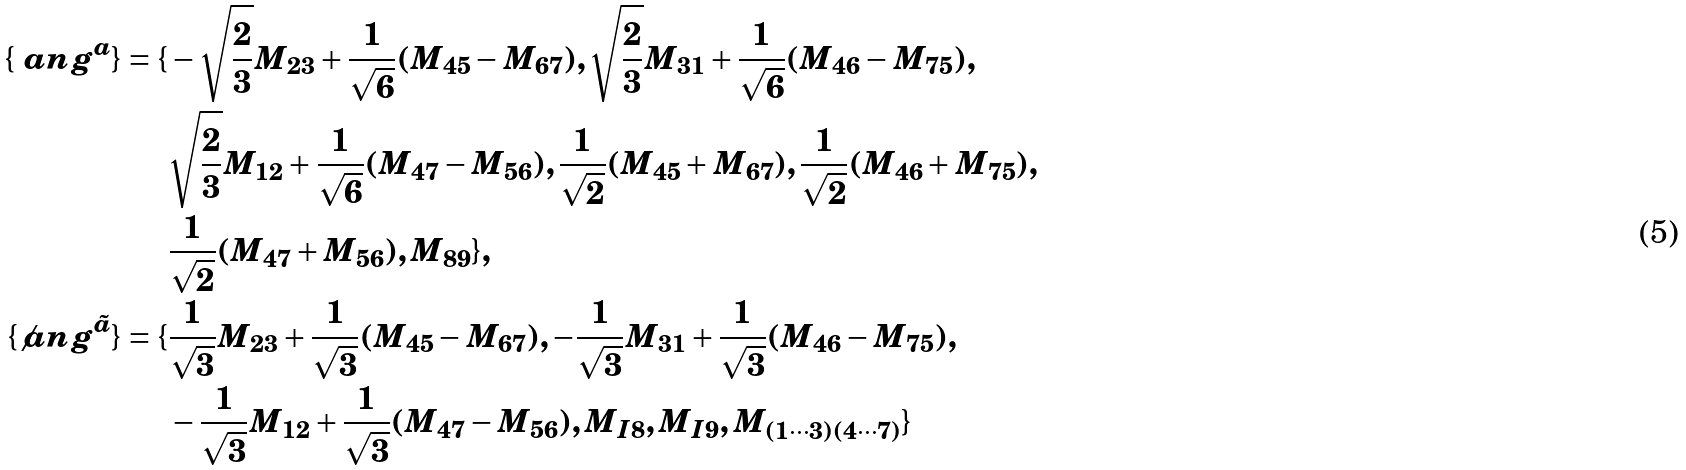Convert formula to latex. <formula><loc_0><loc_0><loc_500><loc_500>\{ \ a n g ^ { a } \} = \{ & - \sqrt { \frac { 2 } { 3 } } M _ { 2 3 } + \frac { 1 } { \sqrt { 6 } } ( M _ { 4 5 } - M _ { 6 7 } ) , \sqrt { \frac { 2 } { 3 } } M _ { 3 1 } + \frac { 1 } { \sqrt { 6 } } ( M _ { 4 6 } - M _ { 7 5 } ) , \\ & \sqrt { \frac { 2 } { 3 } } M _ { 1 2 } + \frac { 1 } { \sqrt { 6 } } ( M _ { 4 7 } - M _ { 5 6 } ) , \frac { 1 } { \sqrt { 2 } } ( M _ { 4 5 } + M _ { 6 7 } ) , \frac { 1 } { \sqrt { 2 } } ( M _ { 4 6 } + M _ { 7 5 } ) , \\ & \frac { 1 } { \sqrt { 2 } } ( M _ { 4 7 } + M _ { 5 6 } ) , M _ { 8 9 } \} , \\ \{ \not a n g ^ { \tilde { a } } \} = \{ & \frac { 1 } { \sqrt { 3 } } M _ { 2 3 } + \frac { 1 } { \sqrt { 3 } } ( M _ { 4 5 } - M _ { 6 7 } ) , - \frac { 1 } { \sqrt { 3 } } M _ { 3 1 } + \frac { 1 } { \sqrt { 3 } } ( M _ { 4 6 } - M _ { 7 5 } ) , \\ & - \frac { 1 } { \sqrt { 3 } } M _ { 1 2 } + \frac { 1 } { \sqrt { 3 } } ( M _ { 4 7 } - M _ { 5 6 } ) , M _ { I 8 } , M _ { I 9 } , M _ { ( 1 \cdots 3 ) ( 4 \cdots 7 ) } \}</formula> 